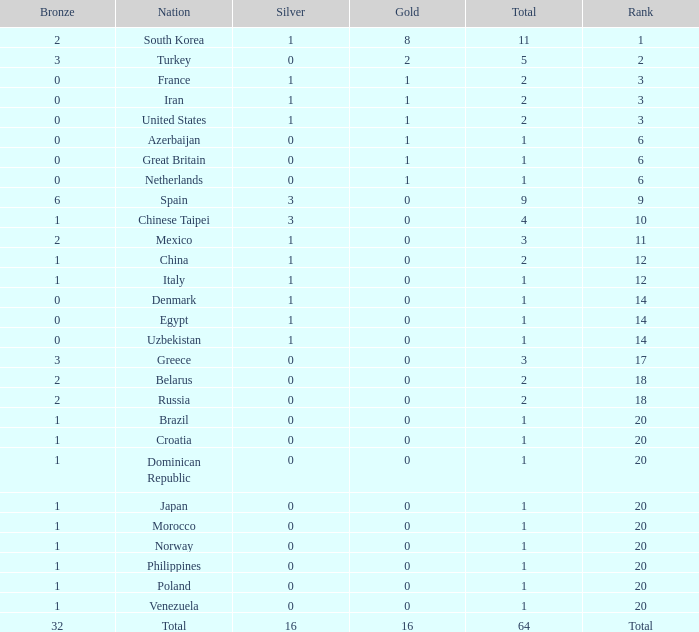Help me parse the entirety of this table. {'header': ['Bronze', 'Nation', 'Silver', 'Gold', 'Total', 'Rank'], 'rows': [['2', 'South Korea', '1', '8', '11', '1'], ['3', 'Turkey', '0', '2', '5', '2'], ['0', 'France', '1', '1', '2', '3'], ['0', 'Iran', '1', '1', '2', '3'], ['0', 'United States', '1', '1', '2', '3'], ['0', 'Azerbaijan', '0', '1', '1', '6'], ['0', 'Great Britain', '0', '1', '1', '6'], ['0', 'Netherlands', '0', '1', '1', '6'], ['6', 'Spain', '3', '0', '9', '9'], ['1', 'Chinese Taipei', '3', '0', '4', '10'], ['2', 'Mexico', '1', '0', '3', '11'], ['1', 'China', '1', '0', '2', '12'], ['1', 'Italy', '1', '0', '1', '12'], ['0', 'Denmark', '1', '0', '1', '14'], ['0', 'Egypt', '1', '0', '1', '14'], ['0', 'Uzbekistan', '1', '0', '1', '14'], ['3', 'Greece', '0', '0', '3', '17'], ['2', 'Belarus', '0', '0', '2', '18'], ['2', 'Russia', '0', '0', '2', '18'], ['1', 'Brazil', '0', '0', '1', '20'], ['1', 'Croatia', '0', '0', '1', '20'], ['1', 'Dominican Republic', '0', '0', '1', '20'], ['1', 'Japan', '0', '0', '1', '20'], ['1', 'Morocco', '0', '0', '1', '20'], ['1', 'Norway', '0', '0', '1', '20'], ['1', 'Philippines', '0', '0', '1', '20'], ['1', 'Poland', '0', '0', '1', '20'], ['1', 'Venezuela', '0', '0', '1', '20'], ['32', 'Total', '16', '16', '64', 'Total']]} What is the average total medals of the nation ranked 1 with less than 1 silver? None. 